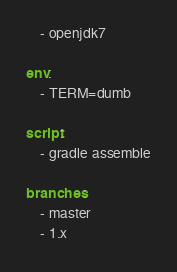<code> <loc_0><loc_0><loc_500><loc_500><_YAML_>    - openjdk7

env:
    - TERM=dumb

script:
    - gradle assemble

branches:
    - master
    - 1.x
</code> 